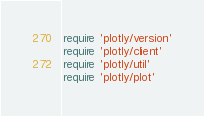Convert code to text. <code><loc_0><loc_0><loc_500><loc_500><_Ruby_>require 'plotly/version'
require 'plotly/client'
require 'plotly/util'
require 'plotly/plot'
</code> 